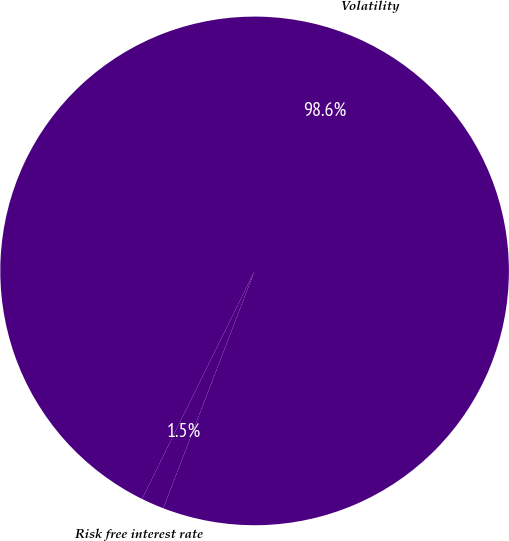Convert chart to OTSL. <chart><loc_0><loc_0><loc_500><loc_500><pie_chart><fcel>Volatility<fcel>Risk free interest rate<nl><fcel>98.55%<fcel>1.45%<nl></chart> 